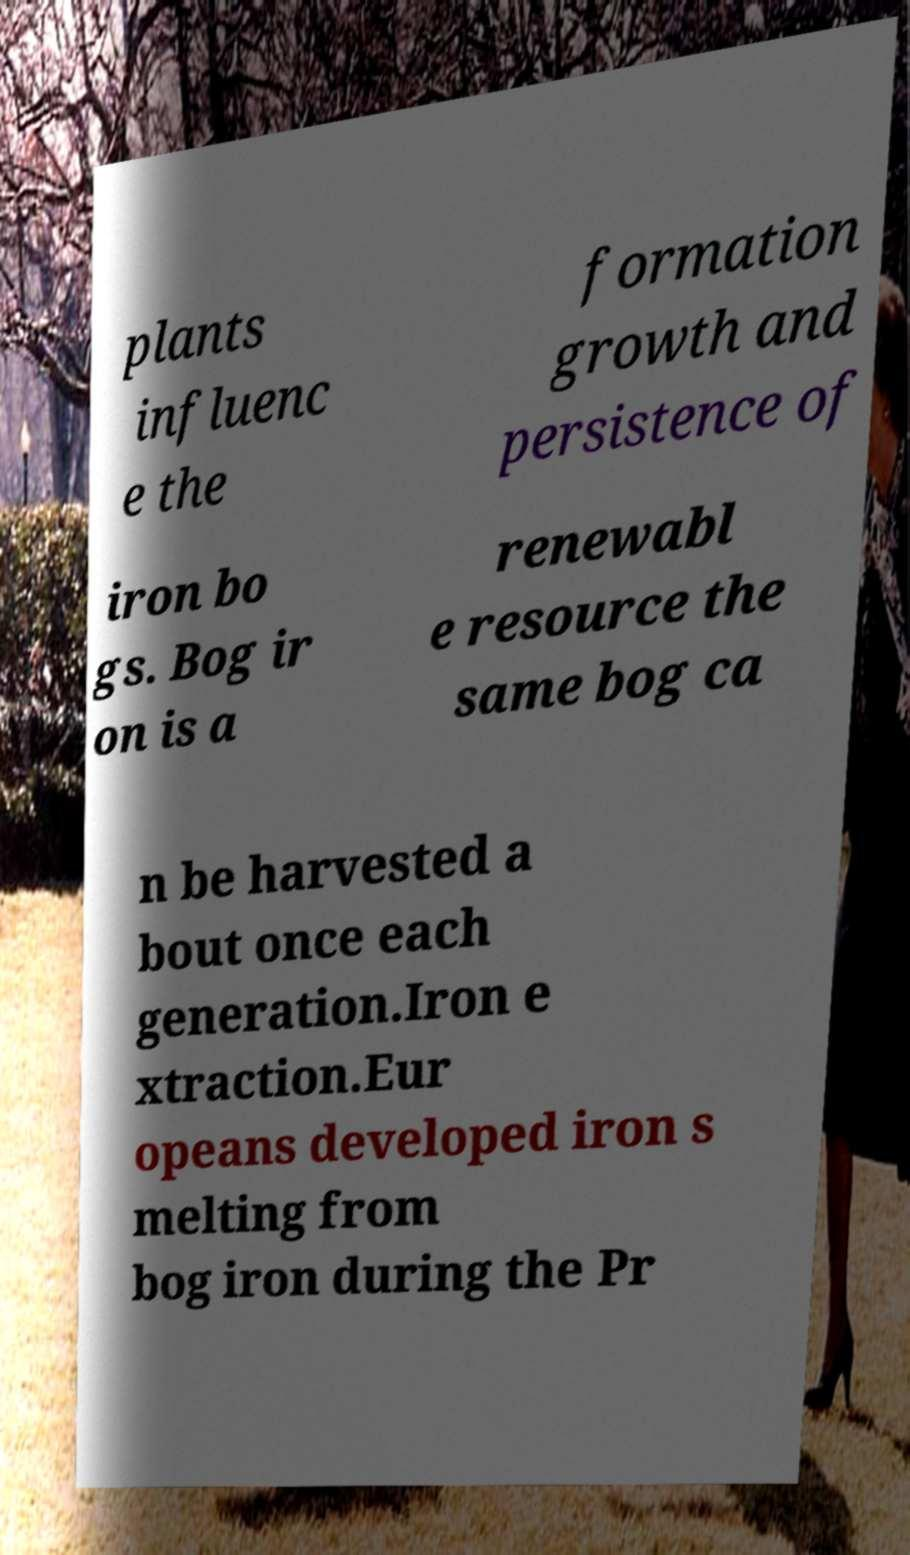Please identify and transcribe the text found in this image. plants influenc e the formation growth and persistence of iron bo gs. Bog ir on is a renewabl e resource the same bog ca n be harvested a bout once each generation.Iron e xtraction.Eur opeans developed iron s melting from bog iron during the Pr 